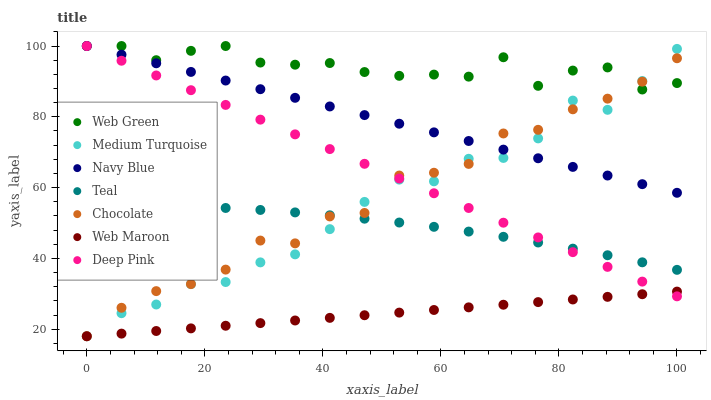Does Web Maroon have the minimum area under the curve?
Answer yes or no. Yes. Does Web Green have the maximum area under the curve?
Answer yes or no. Yes. Does Medium Turquoise have the minimum area under the curve?
Answer yes or no. No. Does Medium Turquoise have the maximum area under the curve?
Answer yes or no. No. Is Web Maroon the smoothest?
Answer yes or no. Yes. Is Medium Turquoise the roughest?
Answer yes or no. Yes. Is Navy Blue the smoothest?
Answer yes or no. No. Is Navy Blue the roughest?
Answer yes or no. No. Does Medium Turquoise have the lowest value?
Answer yes or no. Yes. Does Navy Blue have the lowest value?
Answer yes or no. No. Does Web Green have the highest value?
Answer yes or no. Yes. Does Medium Turquoise have the highest value?
Answer yes or no. No. Is Web Maroon less than Web Green?
Answer yes or no. Yes. Is Web Green greater than Web Maroon?
Answer yes or no. Yes. Does Medium Turquoise intersect Teal?
Answer yes or no. Yes. Is Medium Turquoise less than Teal?
Answer yes or no. No. Is Medium Turquoise greater than Teal?
Answer yes or no. No. Does Web Maroon intersect Web Green?
Answer yes or no. No. 